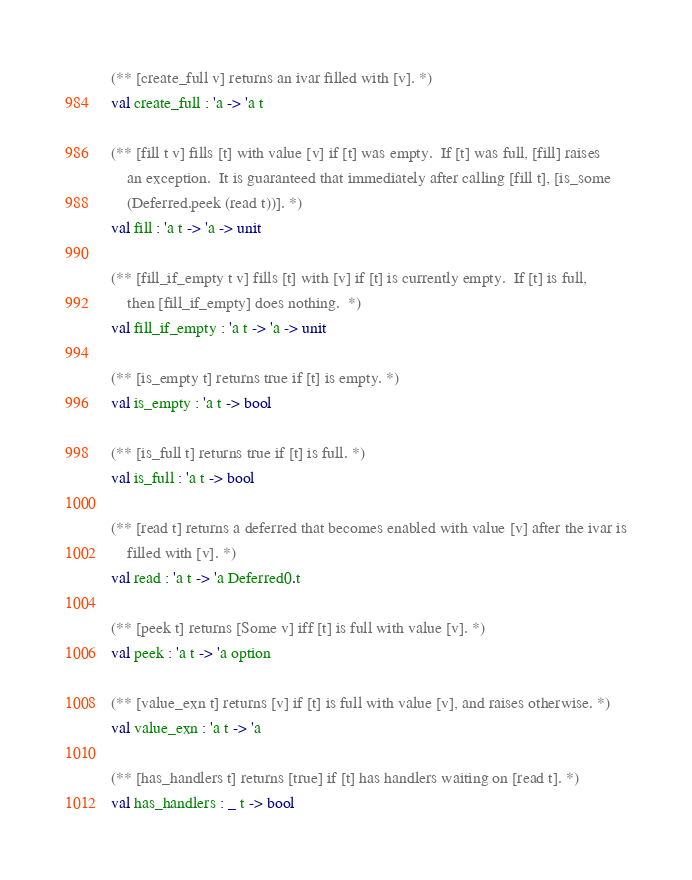<code> <loc_0><loc_0><loc_500><loc_500><_OCaml_>
(** [create_full v] returns an ivar filled with [v]. *)
val create_full : 'a -> 'a t

(** [fill t v] fills [t] with value [v] if [t] was empty.  If [t] was full, [fill] raises
    an exception.  It is guaranteed that immediately after calling [fill t], [is_some
    (Deferred.peek (read t))]. *)
val fill : 'a t -> 'a -> unit

(** [fill_if_empty t v] fills [t] with [v] if [t] is currently empty.  If [t] is full,
    then [fill_if_empty] does nothing.  *)
val fill_if_empty : 'a t -> 'a -> unit

(** [is_empty t] returns true if [t] is empty. *)
val is_empty : 'a t -> bool

(** [is_full t] returns true if [t] is full. *)
val is_full : 'a t -> bool

(** [read t] returns a deferred that becomes enabled with value [v] after the ivar is
    filled with [v]. *)
val read : 'a t -> 'a Deferred0.t

(** [peek t] returns [Some v] iff [t] is full with value [v]. *)
val peek : 'a t -> 'a option

(** [value_exn t] returns [v] if [t] is full with value [v], and raises otherwise. *)
val value_exn : 'a t -> 'a

(** [has_handlers t] returns [true] if [t] has handlers waiting on [read t]. *)
val has_handlers : _ t -> bool
</code> 